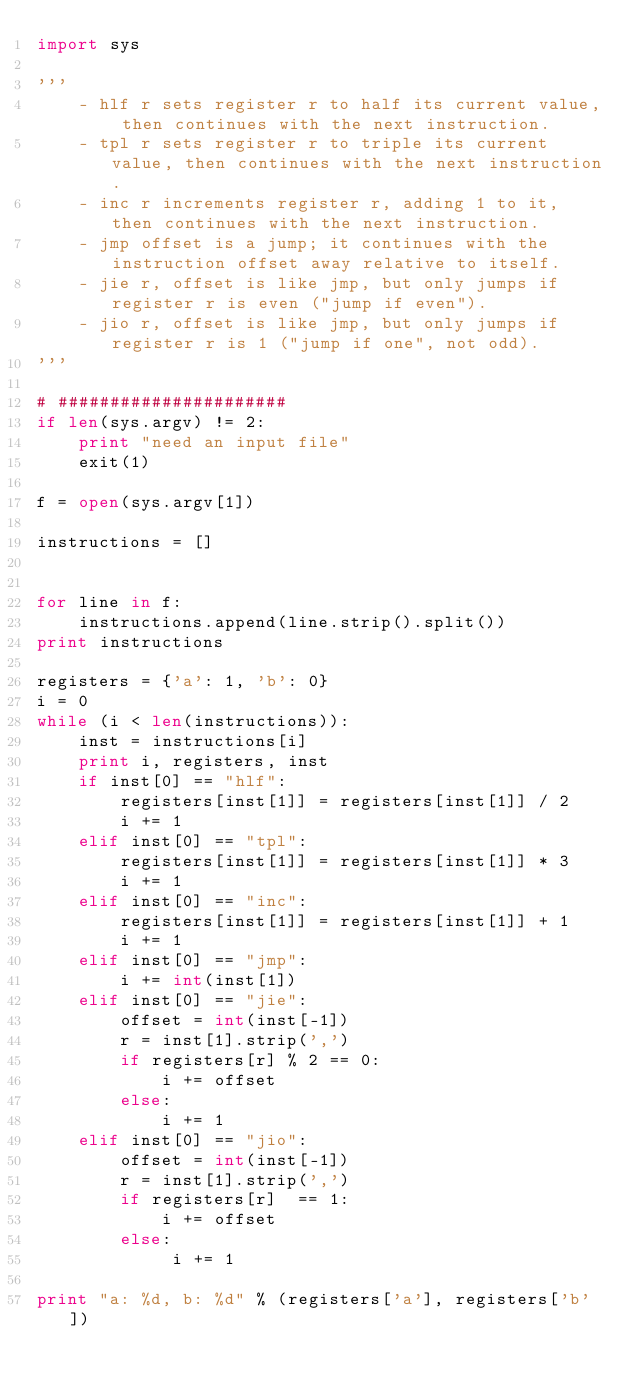Convert code to text. <code><loc_0><loc_0><loc_500><loc_500><_Python_>import sys

'''
    - hlf r sets register r to half its current value, then continues with the next instruction.
    - tpl r sets register r to triple its current value, then continues with the next instruction.
    - inc r increments register r, adding 1 to it, then continues with the next instruction.
    - jmp offset is a jump; it continues with the instruction offset away relative to itself.
    - jie r, offset is like jmp, but only jumps if register r is even ("jump if even").
    - jio r, offset is like jmp, but only jumps if register r is 1 ("jump if one", not odd).
'''

# ######################
if len(sys.argv) != 2:
    print "need an input file"
    exit(1)

f = open(sys.argv[1])

instructions = []


for line in f:
    instructions.append(line.strip().split())
print instructions

registers = {'a': 1, 'b': 0}
i = 0
while (i < len(instructions)):
    inst = instructions[i]
    print i, registers, inst
    if inst[0] == "hlf":
        registers[inst[1]] = registers[inst[1]] / 2
        i += 1
    elif inst[0] == "tpl":
        registers[inst[1]] = registers[inst[1]] * 3
        i += 1
    elif inst[0] == "inc":
        registers[inst[1]] = registers[inst[1]] + 1
        i += 1
    elif inst[0] == "jmp":
        i += int(inst[1])
    elif inst[0] == "jie":
        offset = int(inst[-1])
        r = inst[1].strip(',')
        if registers[r] % 2 == 0:
            i += offset
        else:
            i += 1
    elif inst[0] == "jio":
        offset = int(inst[-1])
        r = inst[1].strip(',')
        if registers[r]  == 1:
            i += offset
        else:
             i += 1

print "a: %d, b: %d" % (registers['a'], registers['b'])
</code> 